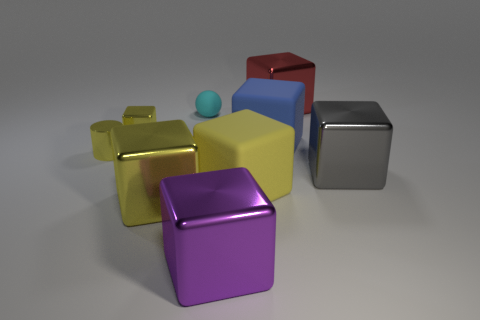Subtract all yellow blocks. How many were subtracted if there are2yellow blocks left? 1 Subtract all brown balls. How many yellow blocks are left? 3 Subtract 1 cubes. How many cubes are left? 6 Subtract all red cubes. How many cubes are left? 6 Subtract all big purple blocks. How many blocks are left? 6 Subtract all gray blocks. Subtract all brown cylinders. How many blocks are left? 6 Add 1 shiny blocks. How many objects exist? 10 Subtract all cylinders. How many objects are left? 8 Subtract 0 gray balls. How many objects are left? 9 Subtract all gray things. Subtract all big red cubes. How many objects are left? 7 